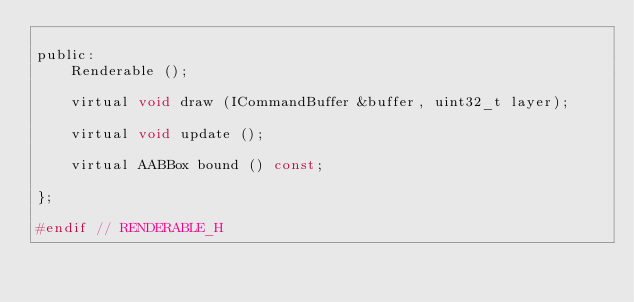<code> <loc_0><loc_0><loc_500><loc_500><_C_>
public:
    Renderable ();

    virtual void draw (ICommandBuffer &buffer, uint32_t layer);

    virtual void update ();

    virtual AABBox bound () const;

};

#endif // RENDERABLE_H
</code> 